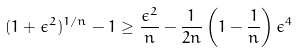Convert formula to latex. <formula><loc_0><loc_0><loc_500><loc_500>( 1 + \epsilon ^ { 2 } ) ^ { 1 / n } - 1 \geq \frac { \epsilon ^ { 2 } } { n } - \frac { 1 } { 2 n } \left ( 1 - \frac { 1 } { n } \right ) \epsilon ^ { 4 }</formula> 